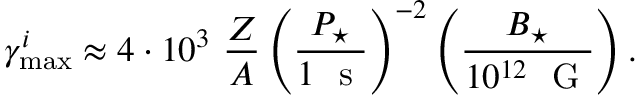<formula> <loc_0><loc_0><loc_500><loc_500>\gamma _ { \max } ^ { i } \approx 4 \cdot 1 0 ^ { 3 } \frac { Z } { A } \left ( \frac { P _ { ^ { * } } } { 1 s } \right ) ^ { - 2 } \left ( \frac { B _ { ^ { * } } } { 1 0 ^ { 1 2 } G } \right ) .</formula> 